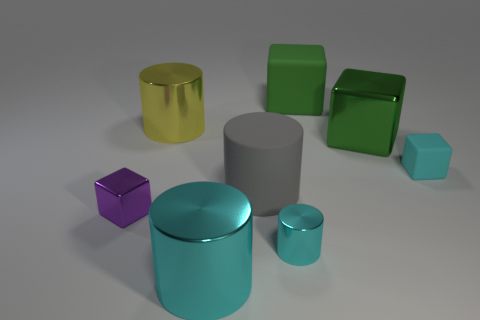What number of other objects are the same color as the big metallic block?
Offer a very short reply. 1. Is the color of the tiny rubber thing the same as the small shiny cylinder?
Your answer should be compact. Yes. How many rubber blocks have the same color as the big metallic cube?
Keep it short and to the point. 1. Is the small purple cube made of the same material as the yellow cylinder?
Provide a succinct answer. Yes. Does the small purple thing have the same shape as the green shiny thing?
Your response must be concise. Yes. Is the number of cyan metallic cylinders left of the small purple metallic cube the same as the number of tiny cyan rubber cubes behind the small cyan shiny thing?
Offer a very short reply. No. What color is the small block that is the same material as the large cyan cylinder?
Your response must be concise. Purple. What number of large cyan cylinders are the same material as the tiny purple cube?
Ensure brevity in your answer.  1. There is a cube on the right side of the big green metal block; is its color the same as the small cylinder?
Your response must be concise. Yes. How many other large metallic objects are the same shape as the green metal object?
Keep it short and to the point. 0. 